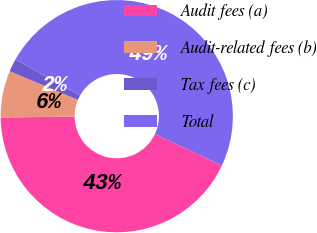Convert chart to OTSL. <chart><loc_0><loc_0><loc_500><loc_500><pie_chart><fcel>Audit fees (a)<fcel>Audit-related fees (b)<fcel>Tax fees (c)<fcel>Total<nl><fcel>42.85%<fcel>6.5%<fcel>1.8%<fcel>48.86%<nl></chart> 